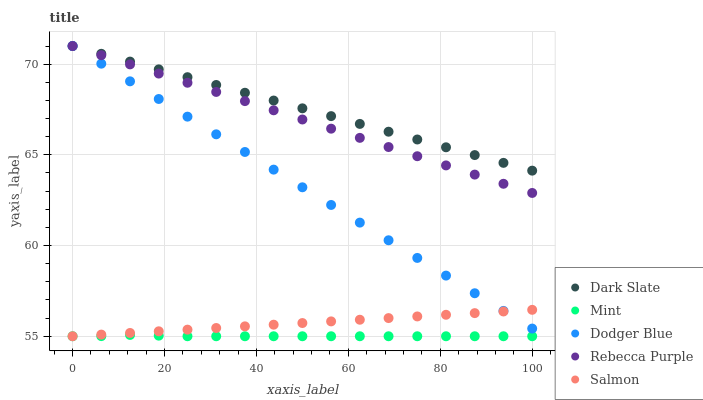Does Mint have the minimum area under the curve?
Answer yes or no. Yes. Does Dark Slate have the maximum area under the curve?
Answer yes or no. Yes. Does Rebecca Purple have the minimum area under the curve?
Answer yes or no. No. Does Rebecca Purple have the maximum area under the curve?
Answer yes or no. No. Is Salmon the smoothest?
Answer yes or no. Yes. Is Mint the roughest?
Answer yes or no. Yes. Is Rebecca Purple the smoothest?
Answer yes or no. No. Is Rebecca Purple the roughest?
Answer yes or no. No. Does Mint have the lowest value?
Answer yes or no. Yes. Does Rebecca Purple have the lowest value?
Answer yes or no. No. Does Dodger Blue have the highest value?
Answer yes or no. Yes. Does Mint have the highest value?
Answer yes or no. No. Is Salmon less than Dark Slate?
Answer yes or no. Yes. Is Rebecca Purple greater than Salmon?
Answer yes or no. Yes. Does Salmon intersect Mint?
Answer yes or no. Yes. Is Salmon less than Mint?
Answer yes or no. No. Is Salmon greater than Mint?
Answer yes or no. No. Does Salmon intersect Dark Slate?
Answer yes or no. No. 